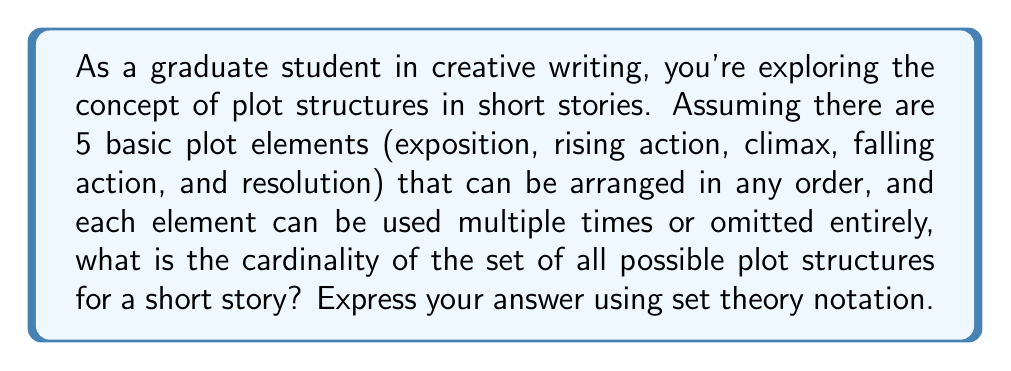Can you solve this math problem? Let's approach this step-by-step:

1) We have 5 basic plot elements to work with. Let's call our set of elements $E = \{e_1, e_2, e_3, e_4, e_5\}$.

2) For each position in the plot structure, we have 6 choices: use any of the 5 elements, or use no element (omission). This can be represented as $E \cup \{\emptyset\}$.

3) A plot structure can be of any length, from 0 (completely omitted) to infinity. This means we're looking at all possible sequences of elements from $E \cup \{\emptyset\}$.

4) In set theory, the set of all sequences over a set $A$ is denoted as $A^\mathbb{N}$, where $\mathbb{N}$ is the set of natural numbers.

5) Therefore, the set of all possible plot structures is $(E \cup \{\emptyset\})^\mathbb{N}$.

6) To find the cardinality, we need to consider:
   - $|E \cup \{\emptyset\}| = 5 + 1 = 6$ (5 elements plus the empty set)
   - $|\mathbb{N}| = \aleph_0$ (the cardinality of the natural numbers)

7) A fundamental result in set theory states that for any set $A$ with $|A| \geq 2$, $|A^\mathbb{N}| = 2^{\aleph_0}= \mathfrak{c}$ (the cardinality of the continuum).

8) Since $|E \cup \{\emptyset\}| = 6 > 2$, we can apply this result.

Therefore, the cardinality of the set of all possible plot structures is $2^{\aleph_0} = \mathfrak{c}$.
Answer: $\left|((E \cup \{\emptyset\})^\mathbb{N})\right| = 2^{\aleph_0} = \mathfrak{c}$ 